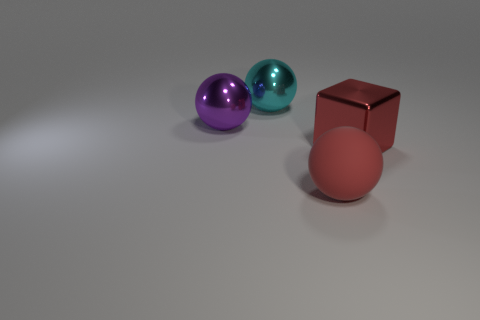What shape is the large object that is left of the large cyan metal ball?
Your answer should be very brief. Sphere. Is the color of the shiny thing that is on the right side of the large red matte object the same as the big object on the left side of the large cyan sphere?
Ensure brevity in your answer.  No. There is a thing that is the same color as the metal block; what is its size?
Make the answer very short. Large. Are there any matte objects?
Offer a terse response. Yes. The big red object that is in front of the big red thing that is on the right side of the red ball on the right side of the big purple thing is what shape?
Provide a succinct answer. Sphere. What number of purple shiny things are on the right side of the large cyan shiny ball?
Your response must be concise. 0. Is the big ball that is in front of the big red shiny block made of the same material as the cube?
Offer a terse response. No. How many other objects are there of the same shape as the large cyan metal thing?
Make the answer very short. 2. How many big metallic blocks are on the left side of the large block on the right side of the rubber thing that is in front of the cyan metallic sphere?
Give a very brief answer. 0. The ball on the left side of the cyan sphere is what color?
Your answer should be very brief. Purple. 